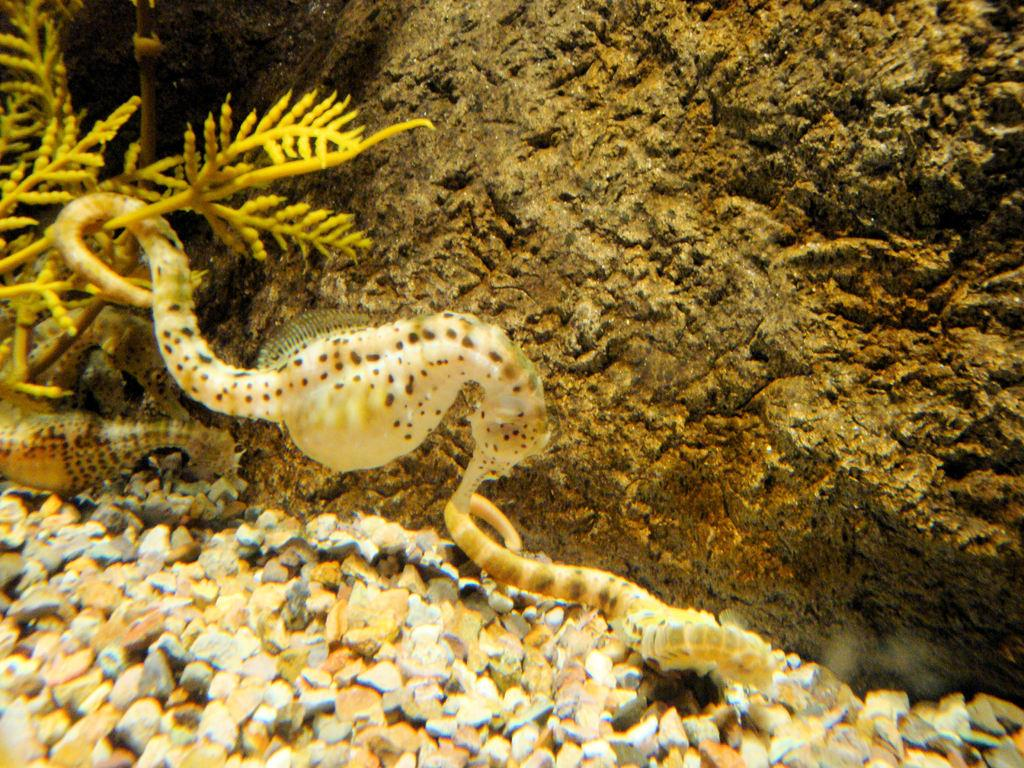What type of environment is shown in the image? The image depicts an underwater scene. What marine creature can be seen in the image? There is a seahorse in the image. What other objects or features are present in the underwater environment? There are plants and marbles in the image. What type of geological formation is visible in the image? There is a rock to the side in the image. Why is the seahorse crying in the image? There is no indication that the seahorse is crying in the image; it is simply a marine creature living in its underwater environment. 